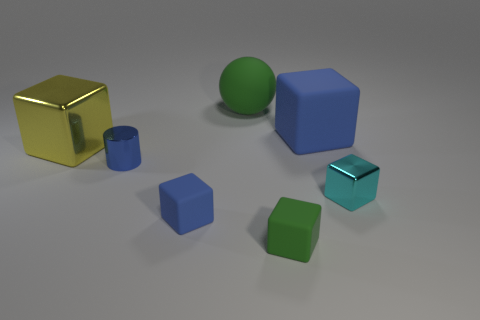Subtract all big yellow metal blocks. How many blocks are left? 4 Subtract all blue cubes. How many cubes are left? 3 Subtract all balls. How many objects are left? 6 Add 3 blue cylinders. How many objects exist? 10 Subtract 1 balls. How many balls are left? 0 Add 7 blue metallic objects. How many blue metallic objects are left? 8 Add 7 large gray objects. How many large gray objects exist? 7 Subtract 0 brown cubes. How many objects are left? 7 Subtract all purple spheres. Subtract all cyan cubes. How many spheres are left? 1 Subtract all green cylinders. How many yellow blocks are left? 1 